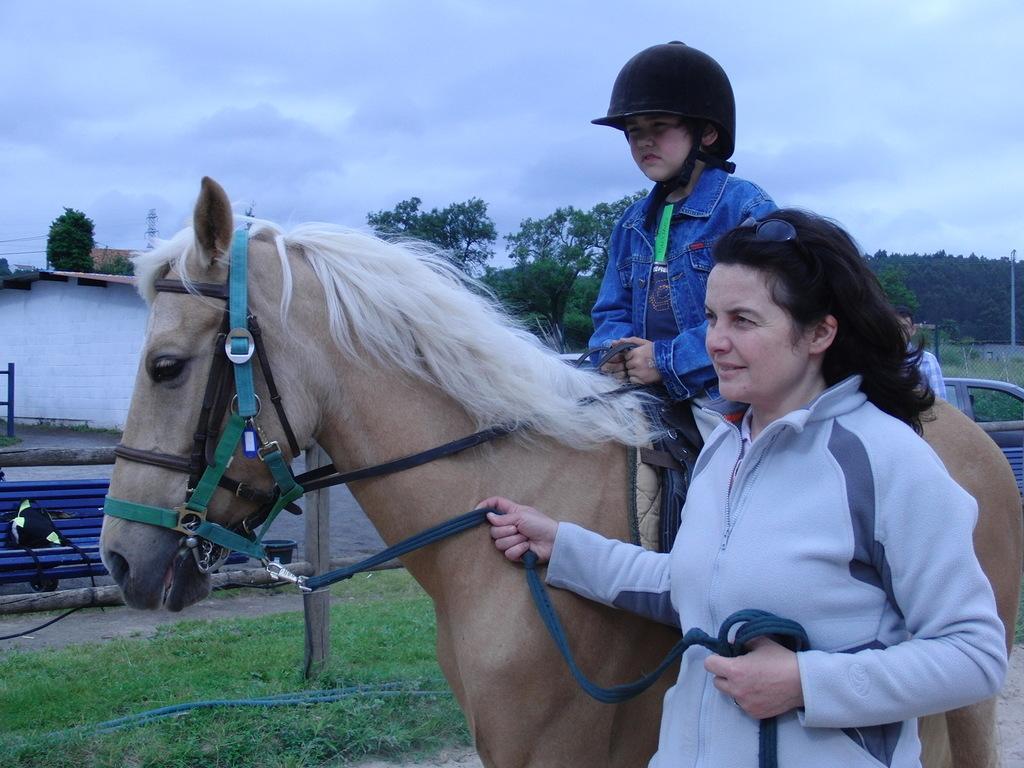In one or two sentences, can you explain what this image depicts? In this picture there is a boy sitting on the horse and there is a woman standing and holding the rope. At the back there is a building behind the railing and there are trees and poles. There is a bench and vehicle behind the railing. At the top there is sky and there are clouds. At the bottom there is grass. 